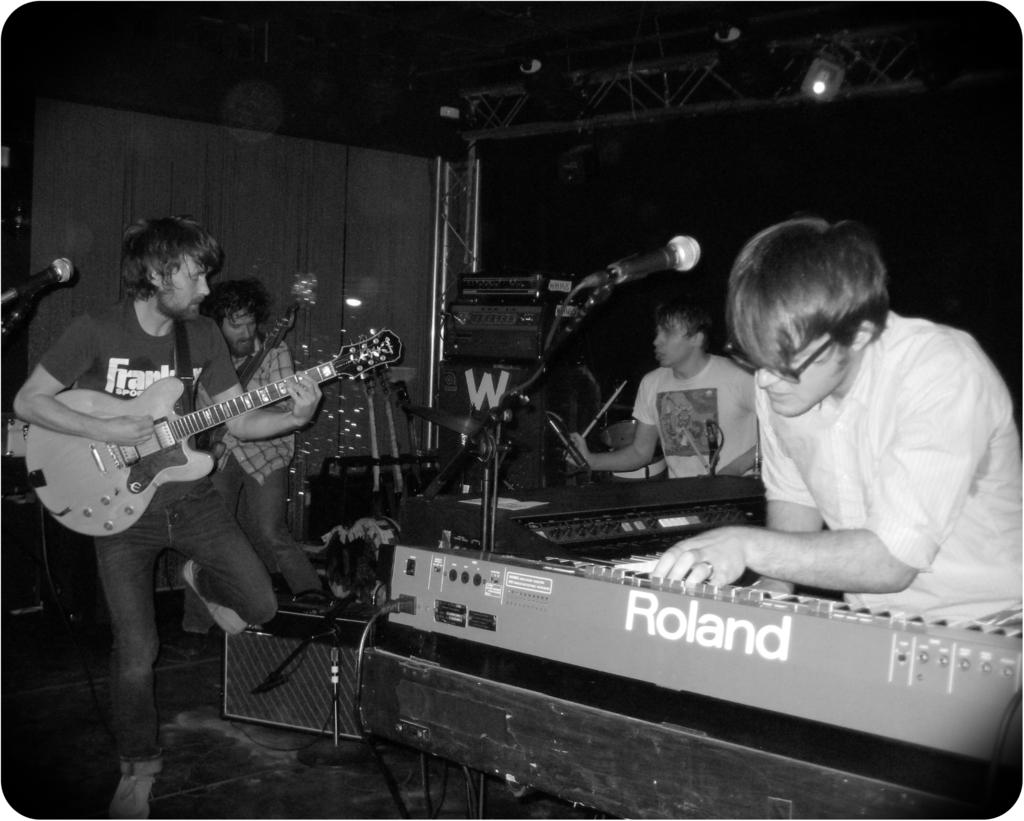What are the people in the room doing? The people in the room are playing musical instruments. What can be seen in the room that is related to amplifying sound? There is a microphone on a stand in the room. How many feathers can be seen floating around the room? There are no feathers visible in the image; the focus is on the people playing musical instruments and the microphone on a stand. 